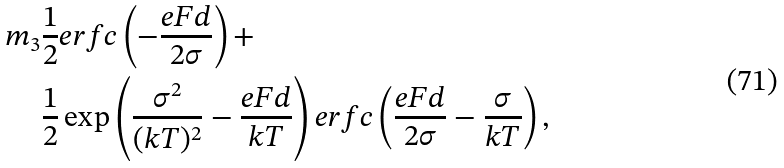Convert formula to latex. <formula><loc_0><loc_0><loc_500><loc_500>m _ { 3 } & \frac { 1 } { 2 } e r f c \left ( - \frac { e F d } { 2 \sigma } \right ) + \\ & \frac { 1 } { 2 } \exp \left ( \frac { \sigma ^ { 2 } } { ( k T ) ^ { 2 } } - \frac { e F d } { k T } \right ) e r f c \left ( \frac { e F d } { 2 \sigma } - \frac { \sigma } { k T } \right ) ,</formula> 